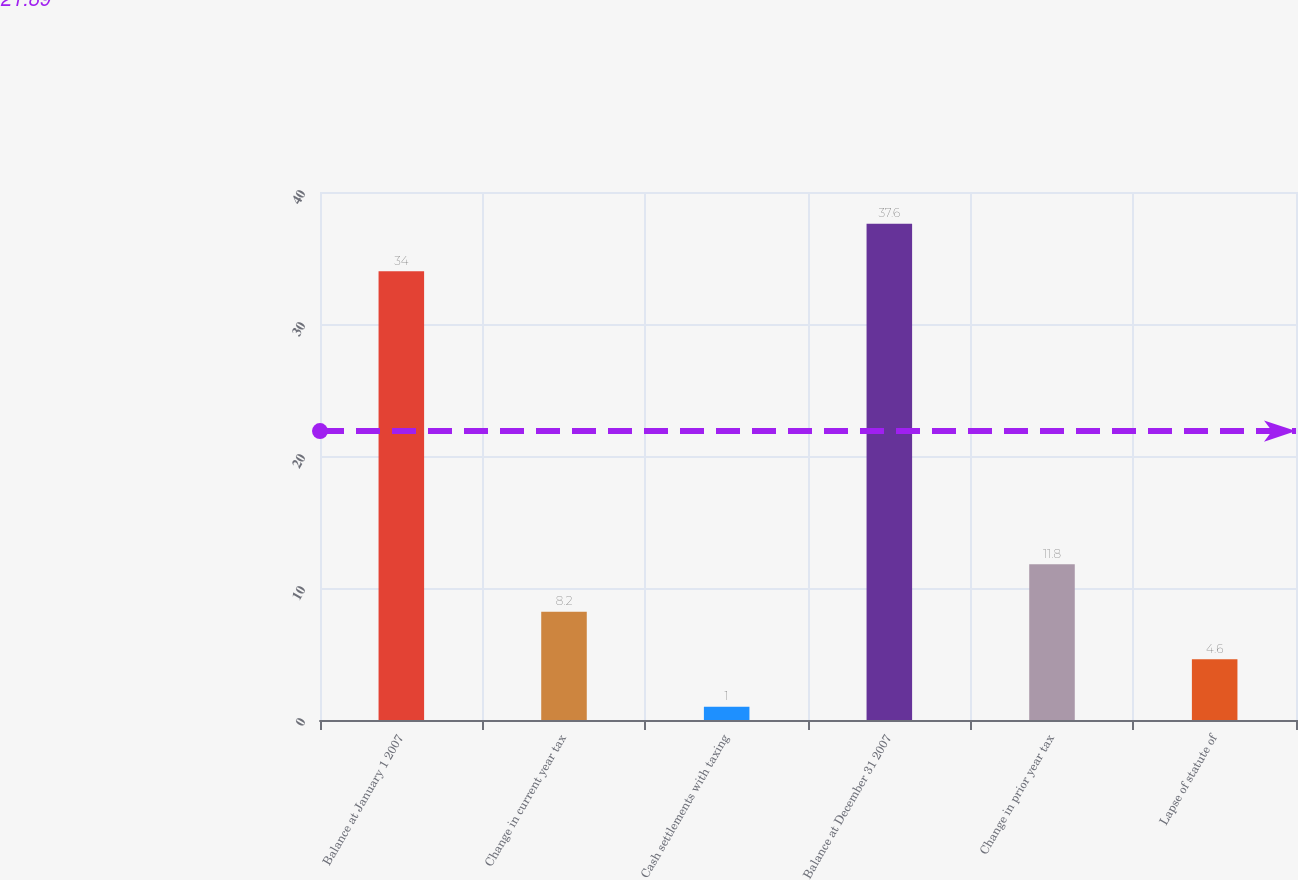Convert chart. <chart><loc_0><loc_0><loc_500><loc_500><bar_chart><fcel>Balance at January 1 2007<fcel>Change in current year tax<fcel>Cash settlements with taxing<fcel>Balance at December 31 2007<fcel>Change in prior year tax<fcel>Lapse of statute of<nl><fcel>34<fcel>8.2<fcel>1<fcel>37.6<fcel>11.8<fcel>4.6<nl></chart> 